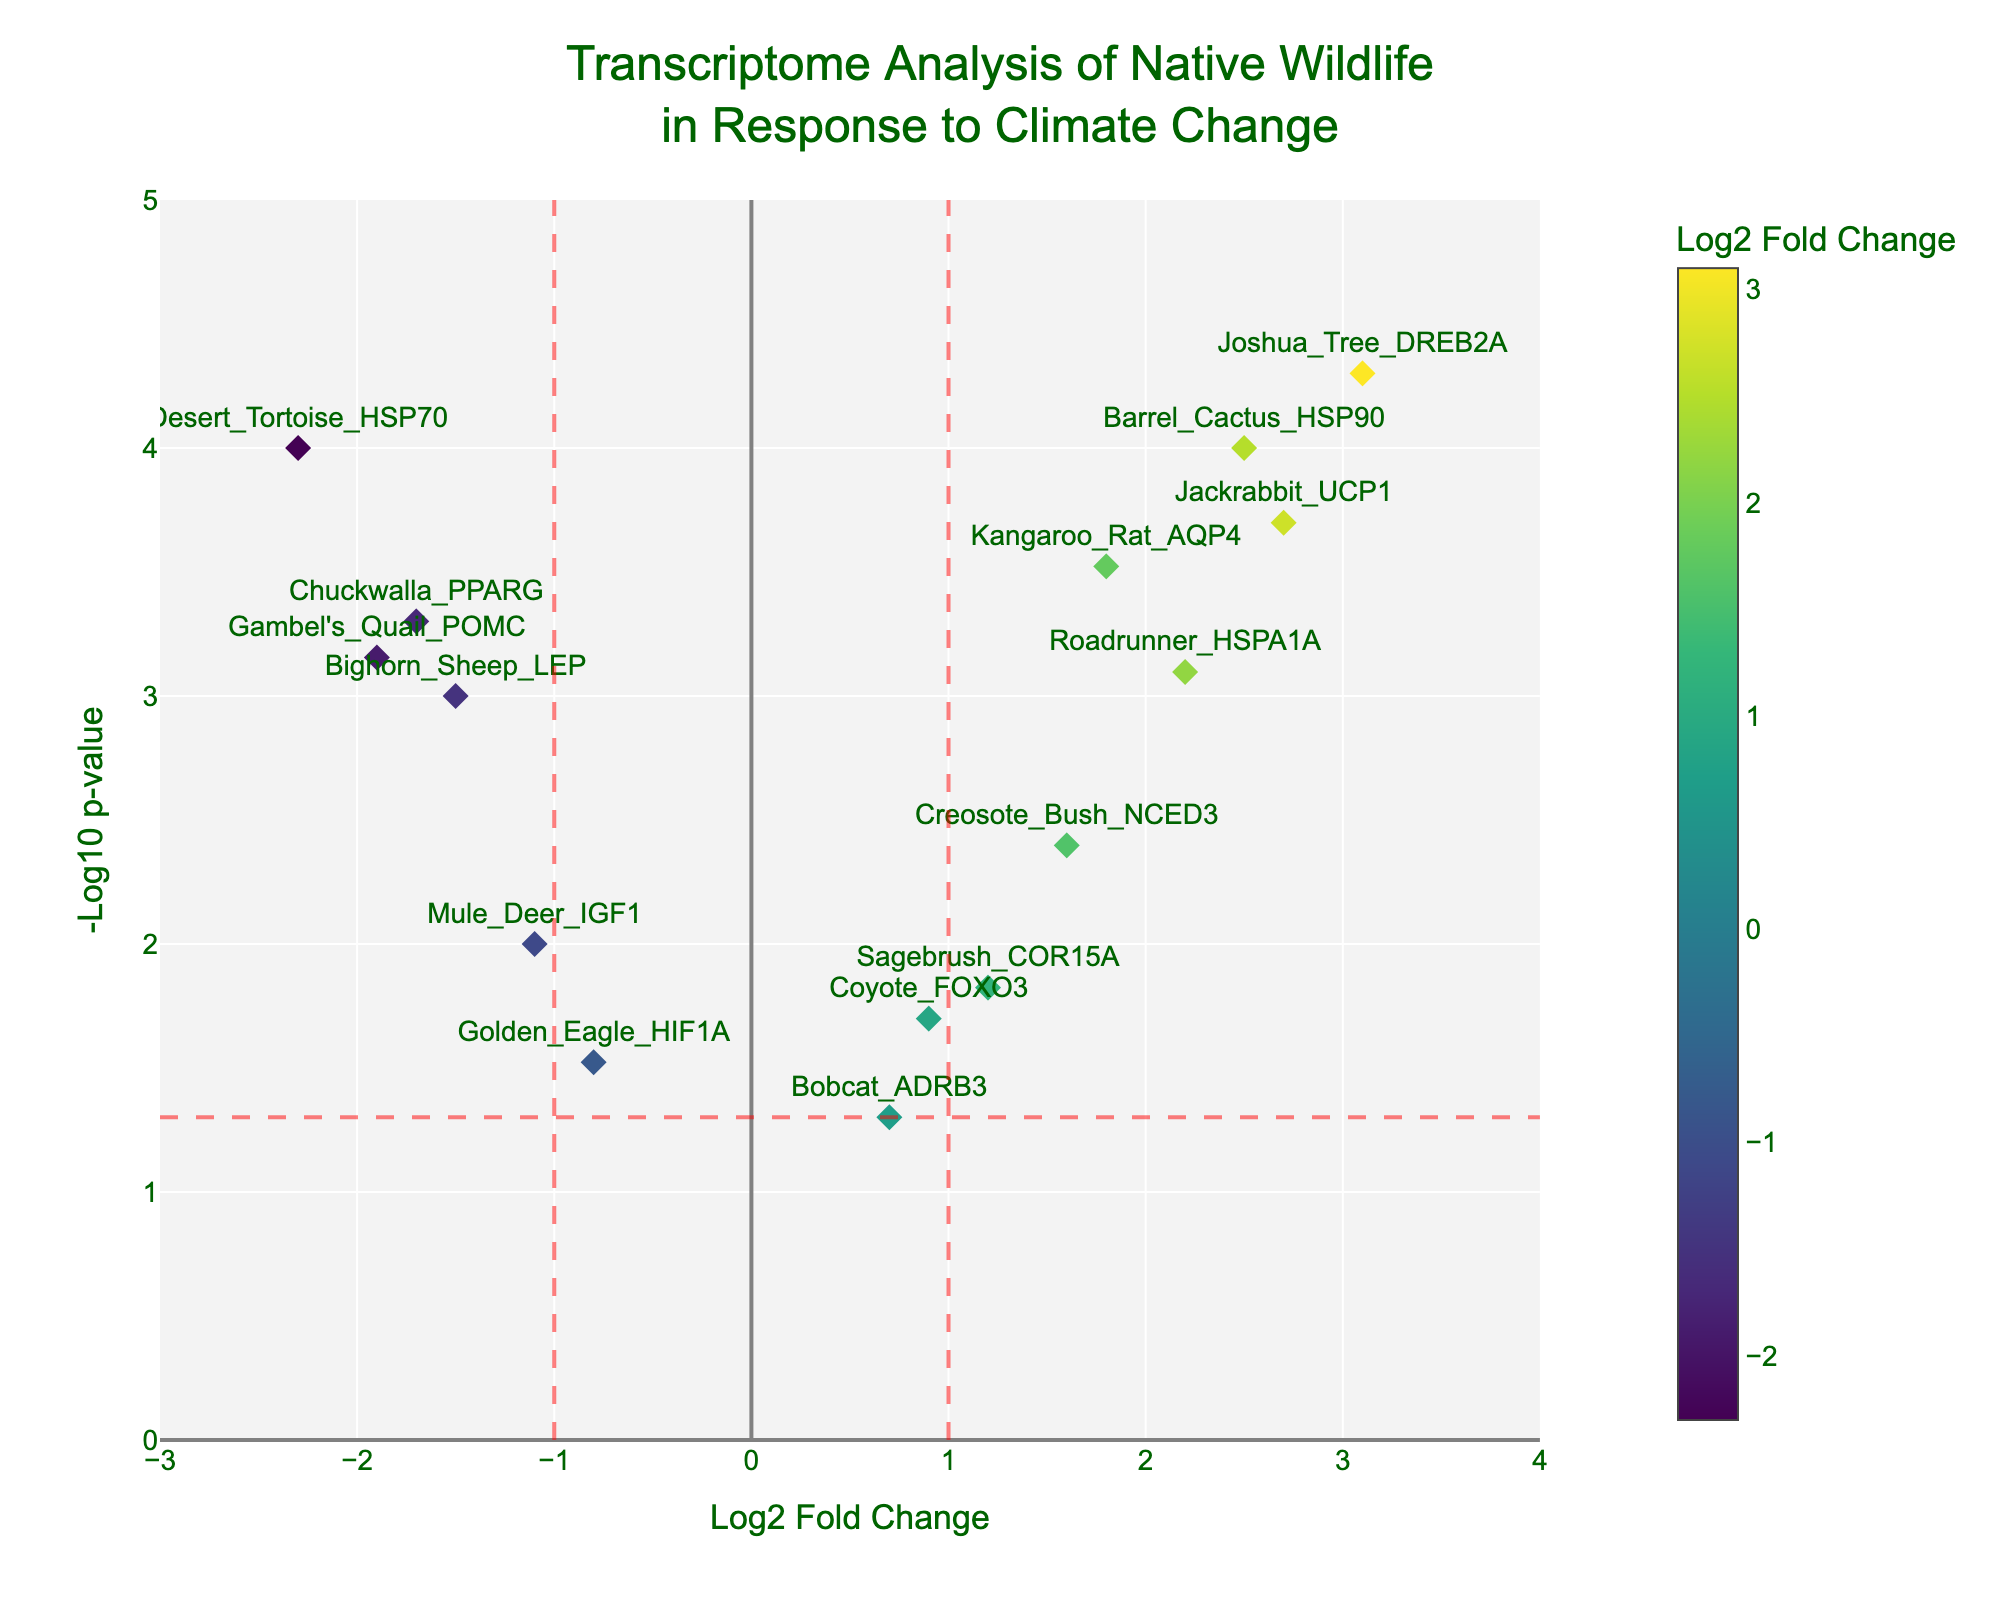How many data points are presented in the plot? The figure includes one marker for each gene displayed. By counting all the markers, we find there are 15 data points corresponding to 15 different genes.
Answer: 15 What gene has the highest -log10(p-value) and what is its value? The highest point on the y-axis represents the gene with the highest -log10(p-value). In this case, the Joshua Tree DREB2A is at the top position with a -log10(p-value) of approximately 4.3.
Answer: Joshua Tree DREB2A, 4.3 Which genes have a log2 fold change less than -1 and a -log10(p-value) greater than 2? The plot shows points where the x-axis is less than -1 and the y-axis is greater than 2. The genes Desert Tortoise HSP70, Bighorn Sheep LEP, and Chuckwalla PPARG meet this criterion.
Answer: Desert Tortoise HSP70, Bighorn Sheep LEP, Chuckwalla PPARG Identify the point on the plot with the largest positive log2 fold change. Looking at the x-axis, the point furthest to the right indicates the largest positive log2 fold change, which is Joshua Tree DREB2A with a log2 fold change of 3.1.
Answer: Joshua Tree DREB2A Are there any genes with a -log10(p-value) less than 1? If so, list them. By checking the y-axis scale, we see that a point below the value of 1 corresponds to a -log10(p-value) less than 1. The gene Golden Eagle HIF1A has a -log10(p-value) around 1.52.
Answer: Golden Eagle HIF1A Which genes have a significant p-value (less than 0.05) but a relatively small change in log2 fold change (between -1 and 1)? First, identify genes with -log10(p-value) greater than 1.3, indicating significant p-values (<0.05). Then, filter those within the log2 fold change range of -1 to 1. The genes Coyote FOXO3, Sagebrush COR15A, Mule Deer IGF1, and Bobcat ADRB3 fit these criteria.
Answer: Coyote FOXO3, Sagebrush COR15A, Mule Deer IGF1, Bobcat ADRB3 What is the range of -log10(p-value) in this plot? Review the minimum and maximum values on the y-axis to determine the range. The plot ranges from approximately 0 to 4.3 on the -log10(p-value) scale.
Answer: 0 to 4.3 Which gene shows the most negative effect in response to climate change (most negative log2 fold change)? Look for the point furthest to the left on the x-axis. Desert Tortoise HSP70 has the most negative log2 fold change of -2.3.
Answer: Desert Tortoise HSP70 